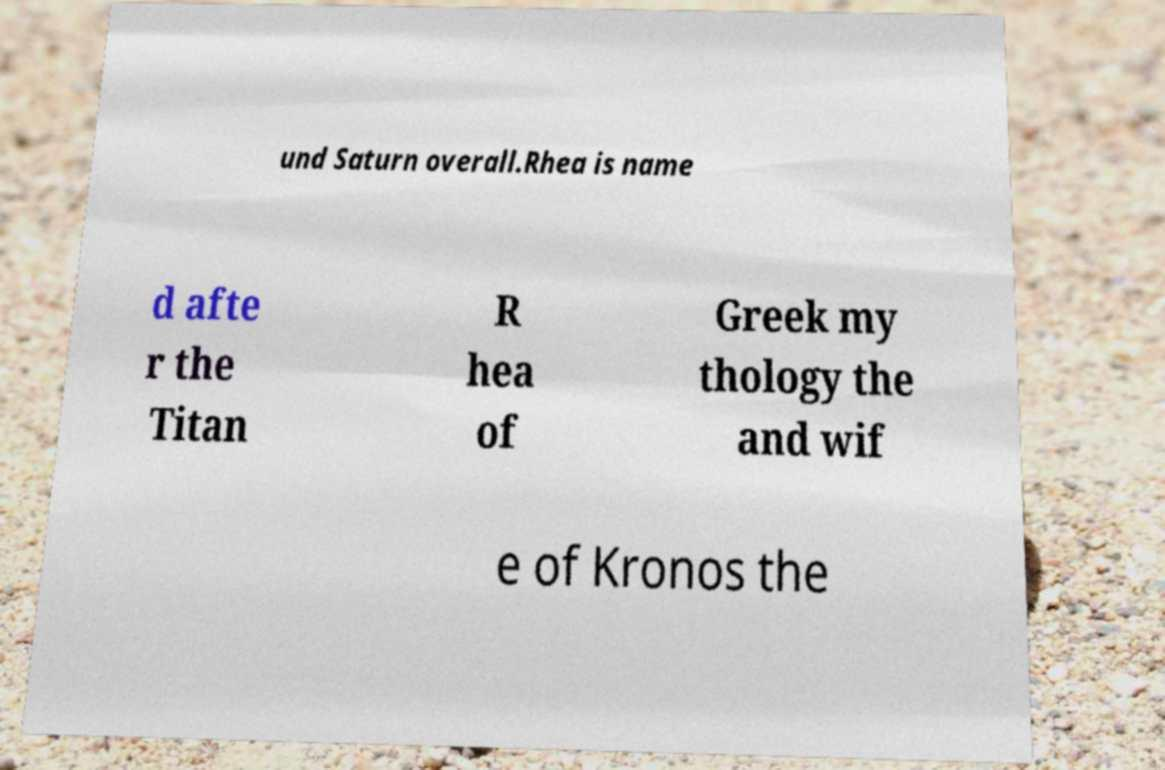Could you extract and type out the text from this image? und Saturn overall.Rhea is name d afte r the Titan R hea of Greek my thology the and wif e of Kronos the 